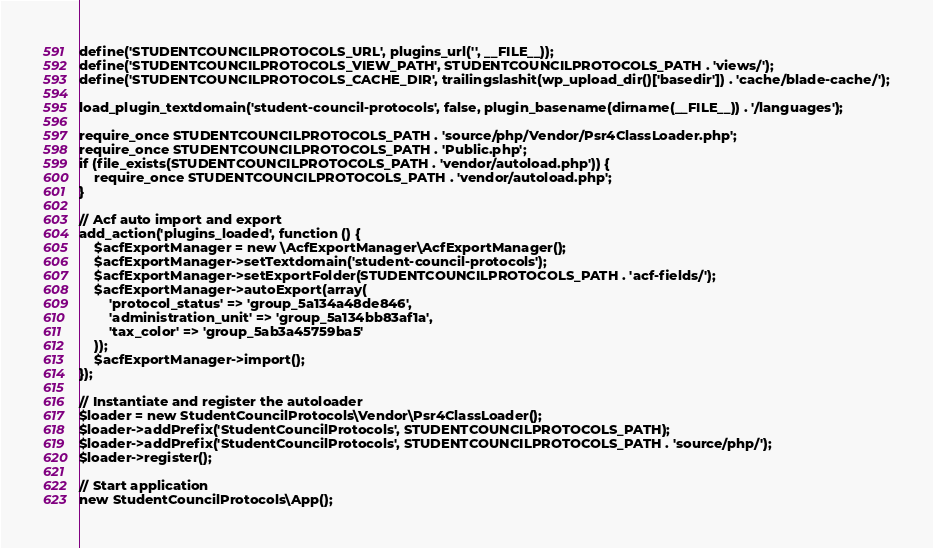<code> <loc_0><loc_0><loc_500><loc_500><_PHP_>define('STUDENTCOUNCILPROTOCOLS_URL', plugins_url('', __FILE__));
define('STUDENTCOUNCILPROTOCOLS_VIEW_PATH', STUDENTCOUNCILPROTOCOLS_PATH . 'views/');
define('STUDENTCOUNCILPROTOCOLS_CACHE_DIR', trailingslashit(wp_upload_dir()['basedir']) . 'cache/blade-cache/');

load_plugin_textdomain('student-council-protocols', false, plugin_basename(dirname(__FILE__)) . '/languages');

require_once STUDENTCOUNCILPROTOCOLS_PATH . 'source/php/Vendor/Psr4ClassLoader.php';
require_once STUDENTCOUNCILPROTOCOLS_PATH . 'Public.php';
if (file_exists(STUDENTCOUNCILPROTOCOLS_PATH . 'vendor/autoload.php')) {
    require_once STUDENTCOUNCILPROTOCOLS_PATH . 'vendor/autoload.php';
}

// Acf auto import and export
add_action('plugins_loaded', function () {
    $acfExportManager = new \AcfExportManager\AcfExportManager();
    $acfExportManager->setTextdomain('student-council-protocols');
    $acfExportManager->setExportFolder(STUDENTCOUNCILPROTOCOLS_PATH . 'acf-fields/');
    $acfExportManager->autoExport(array(
        'protocol_status' => 'group_5a134a48de846',
        'administration_unit' => 'group_5a134bb83af1a',
        'tax_color' => 'group_5ab3a45759ba5'
    ));
    $acfExportManager->import();
});

// Instantiate and register the autoloader
$loader = new StudentCouncilProtocols\Vendor\Psr4ClassLoader();
$loader->addPrefix('StudentCouncilProtocols', STUDENTCOUNCILPROTOCOLS_PATH);
$loader->addPrefix('StudentCouncilProtocols', STUDENTCOUNCILPROTOCOLS_PATH . 'source/php/');
$loader->register();

// Start application
new StudentCouncilProtocols\App();
</code> 